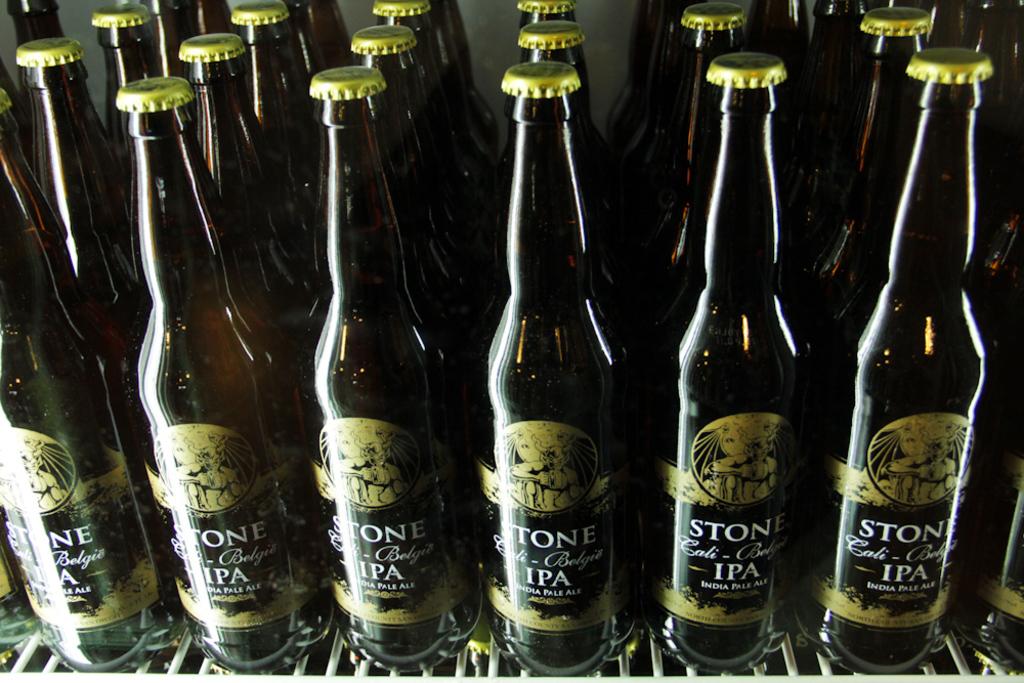What phrase is under ipa?
Provide a succinct answer. India pale ale. 